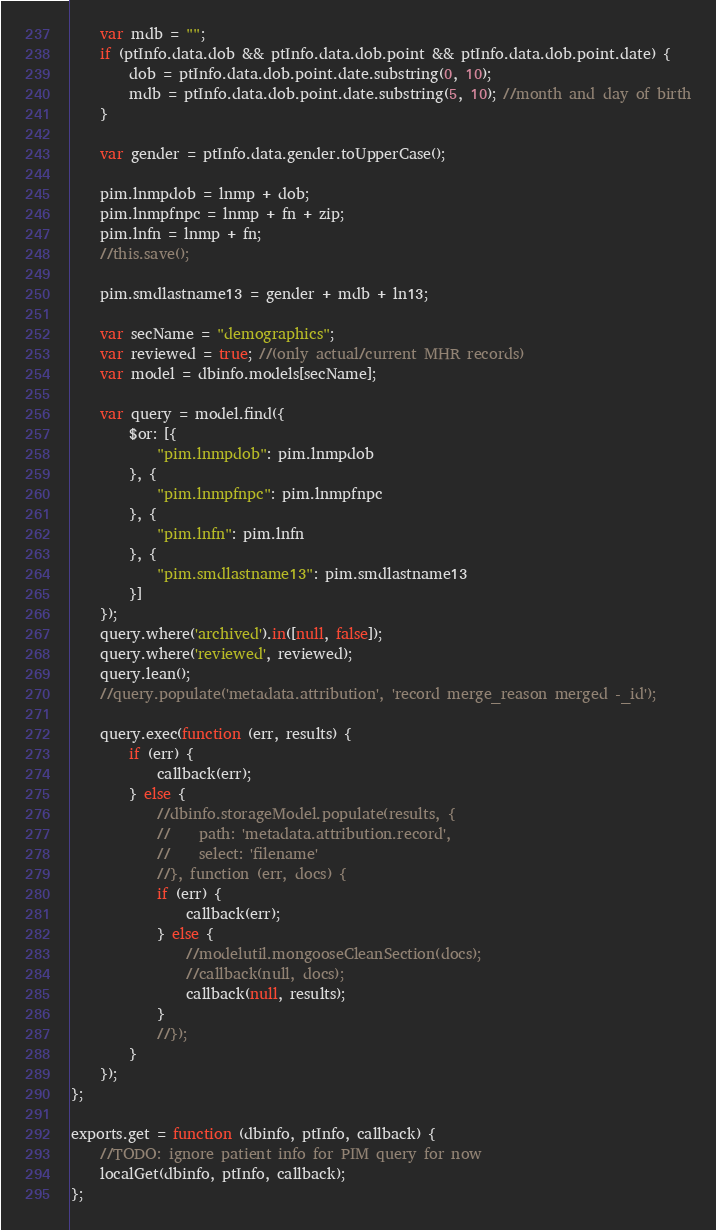Convert code to text. <code><loc_0><loc_0><loc_500><loc_500><_JavaScript_>    var mdb = "";
    if (ptInfo.data.dob && ptInfo.data.dob.point && ptInfo.data.dob.point.date) {
        dob = ptInfo.data.dob.point.date.substring(0, 10);
        mdb = ptInfo.data.dob.point.date.substring(5, 10); //month and day of birth
    }

    var gender = ptInfo.data.gender.toUpperCase();

    pim.lnmpdob = lnmp + dob;
    pim.lnmpfnpc = lnmp + fn + zip;
    pim.lnfn = lnmp + fn;
    //this.save();

    pim.smdlastname13 = gender + mdb + ln13;

    var secName = "demographics";
    var reviewed = true; //(only actual/current MHR records)
    var model = dbinfo.models[secName];

    var query = model.find({
        $or: [{
            "pim.lnmpdob": pim.lnmpdob
        }, {
            "pim.lnmpfnpc": pim.lnmpfnpc
        }, {
            "pim.lnfn": pim.lnfn
        }, {
            "pim.smdlastname13": pim.smdlastname13
        }]
    });
    query.where('archived').in([null, false]);
    query.where('reviewed', reviewed);
    query.lean();
    //query.populate('metadata.attribution', 'record merge_reason merged -_id');

    query.exec(function (err, results) {
        if (err) {
            callback(err);
        } else {
            //dbinfo.storageModel.populate(results, {
            //    path: 'metadata.attribution.record',
            //    select: 'filename'
            //}, function (err, docs) {
            if (err) {
                callback(err);
            } else {
                //modelutil.mongooseCleanSection(docs);
                //callback(null, docs);
                callback(null, results);
            }
            //});
        }
    });
};

exports.get = function (dbinfo, ptInfo, callback) {
    //TODO: ignore patient info for PIM query for now
    localGet(dbinfo, ptInfo, callback);
};
</code> 